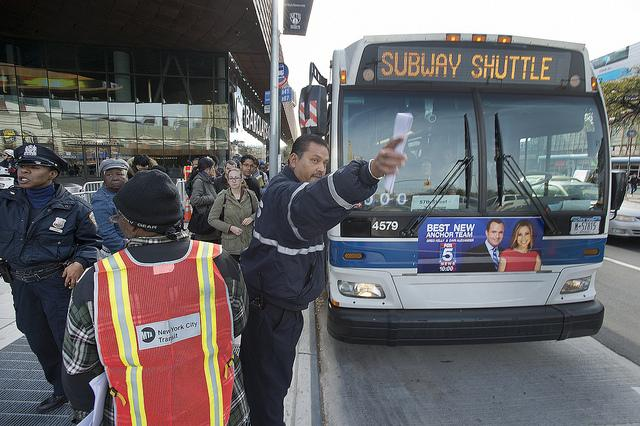What profession is the black man in the blue cap on the left? Please explain your reasoning. police officer. The profession is the police. 